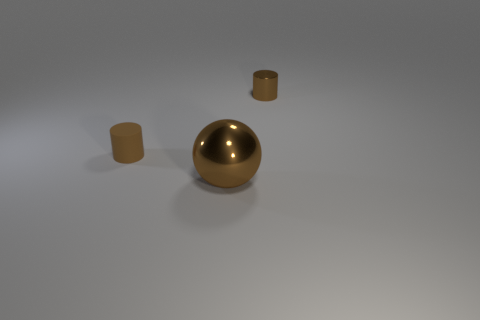Is there any other thing that is the same size as the brown ball?
Keep it short and to the point. No. Is the material of the small brown cylinder that is behind the brown rubber object the same as the big brown thing?
Give a very brief answer. Yes. There is a brown shiny object on the left side of the brown cylinder to the right of the big brown metal thing; are there any small brown metallic things behind it?
Give a very brief answer. Yes. How many cylinders are large brown metallic objects or tiny red shiny things?
Your answer should be very brief. 0. There is a tiny cylinder on the left side of the large brown metal sphere; what is its material?
Offer a terse response. Rubber. What size is the metal ball that is the same color as the small rubber thing?
Provide a succinct answer. Large. Does the cylinder that is to the left of the big brown metal sphere have the same color as the cylinder that is to the right of the ball?
Give a very brief answer. Yes. What number of things are red cylinders or small brown cylinders?
Offer a terse response. 2. How many other objects are the same shape as the large brown object?
Keep it short and to the point. 0. Is the small brown cylinder that is behind the brown rubber cylinder made of the same material as the object on the left side of the ball?
Your answer should be very brief. No. 